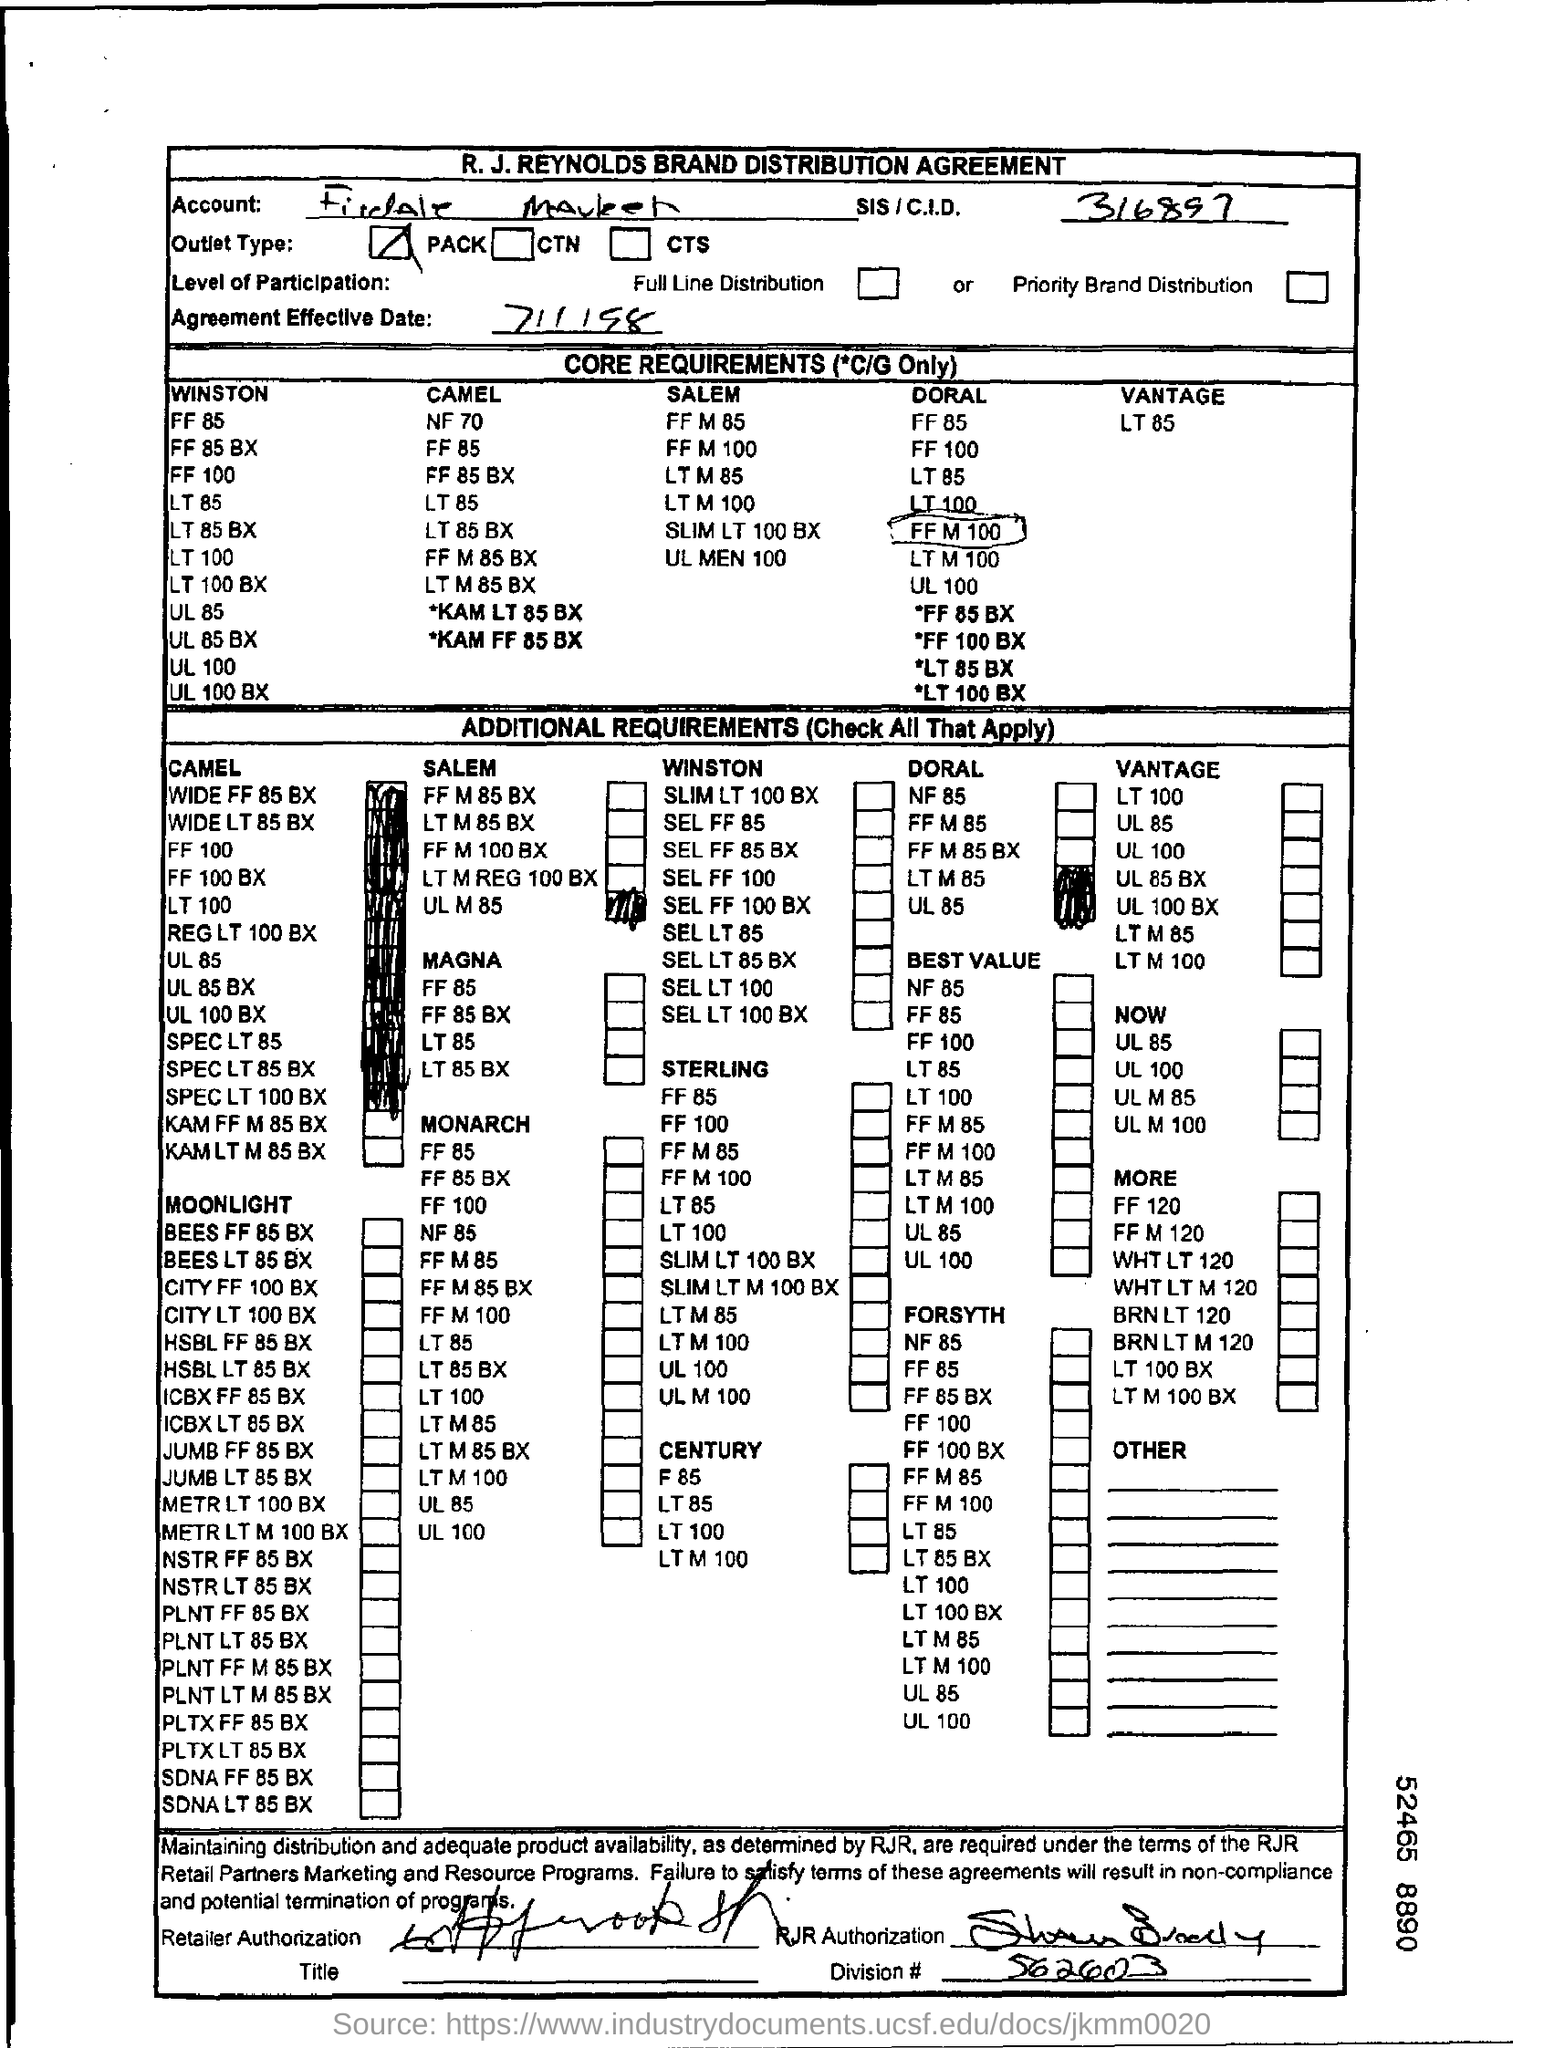Indicate a few pertinent items in this graphic. The agreement became effective on July 1, 1998. What is the result of the division of 562603... by...? The division mentioned in the form is 562603... The outlet type is PACK. The SIS/C.I.D. is a system or process. The number 316897 is associated with it. 